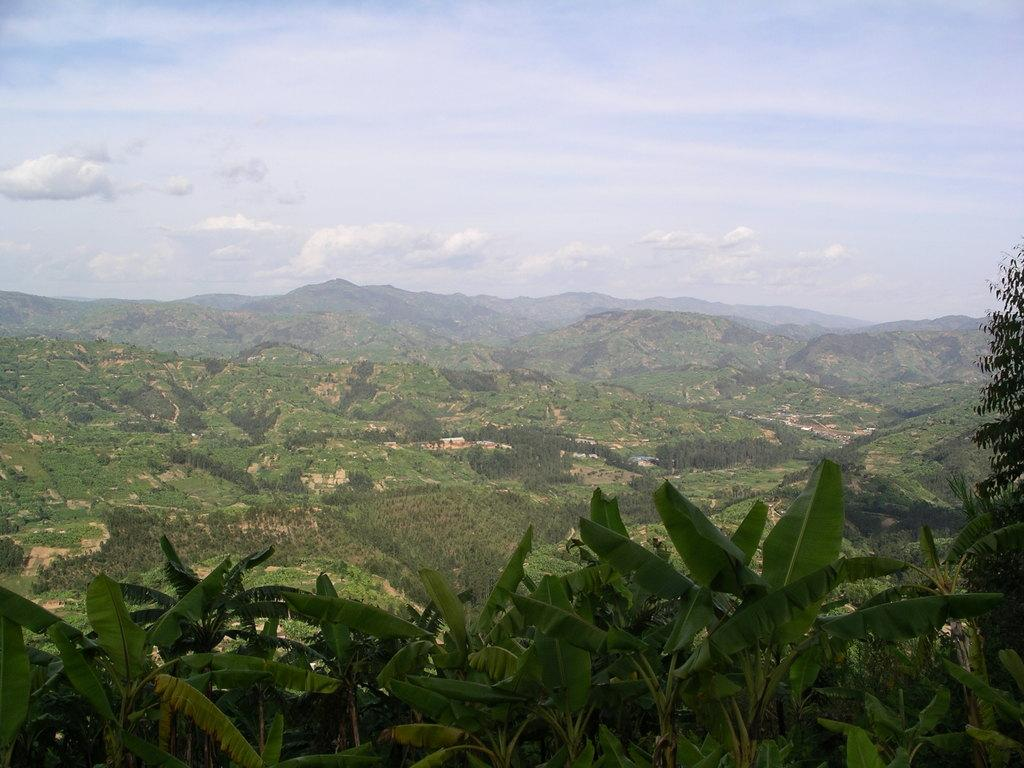What type of vegetation can be seen in the foreground of the image? There are trees in the foreground of the image. What type of landscape feature is visible in the background of the image? There are hills visible in the background of the image. What can be seen in the skyward in the image? Clouds are present in the sky. What type of story is the fireman telling in the image? There is no fireman present in the image, so no story can be observed. What kind of haircut does the tree in the foreground have? Trees do not have haircuts, as they are not sentient beings. 